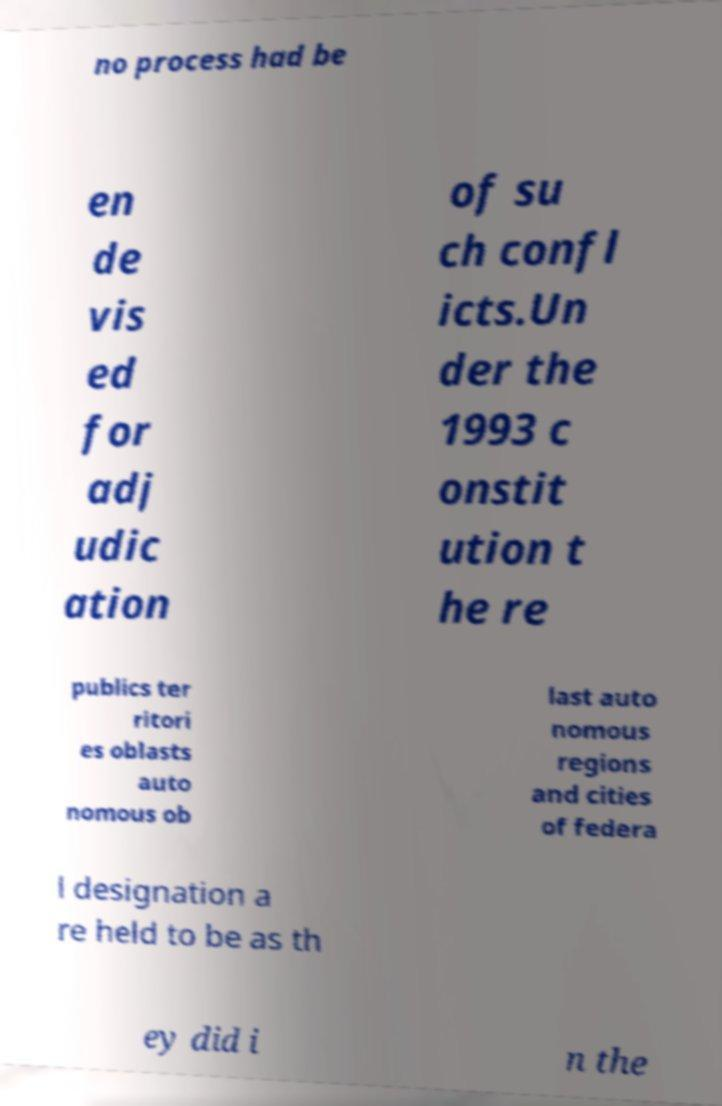For documentation purposes, I need the text within this image transcribed. Could you provide that? no process had be en de vis ed for adj udic ation of su ch confl icts.Un der the 1993 c onstit ution t he re publics ter ritori es oblasts auto nomous ob last auto nomous regions and cities of federa l designation a re held to be as th ey did i n the 